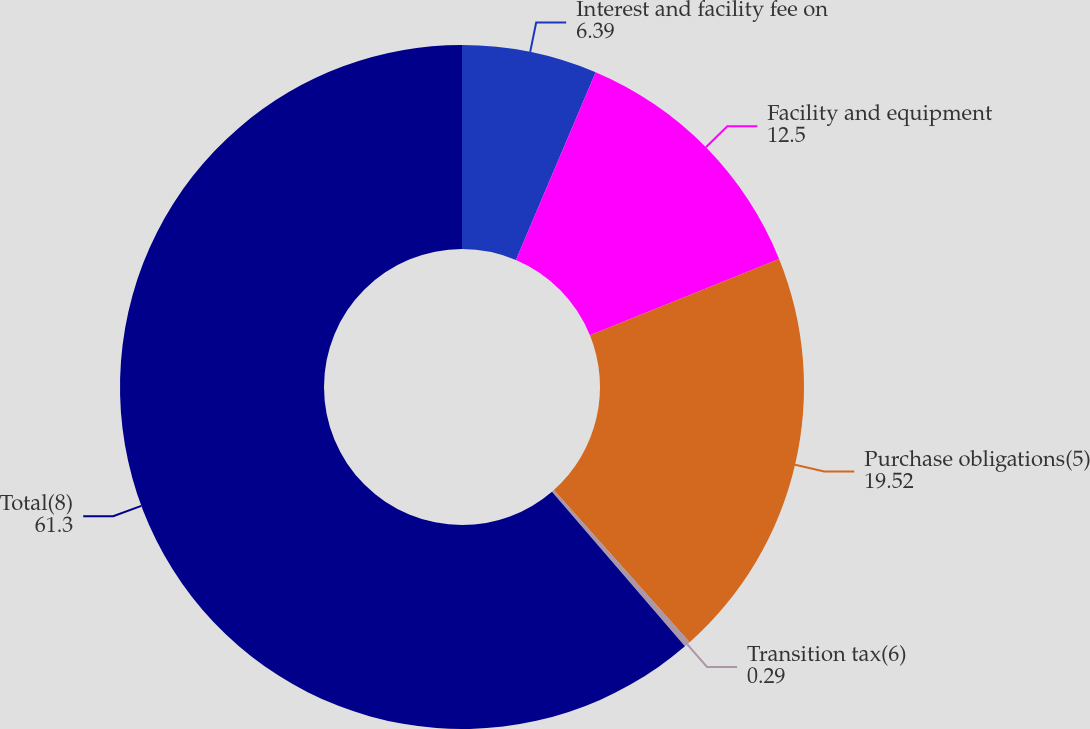Convert chart to OTSL. <chart><loc_0><loc_0><loc_500><loc_500><pie_chart><fcel>Interest and facility fee on<fcel>Facility and equipment<fcel>Purchase obligations(5)<fcel>Transition tax(6)<fcel>Total(8)<nl><fcel>6.39%<fcel>12.5%<fcel>19.52%<fcel>0.29%<fcel>61.3%<nl></chart> 